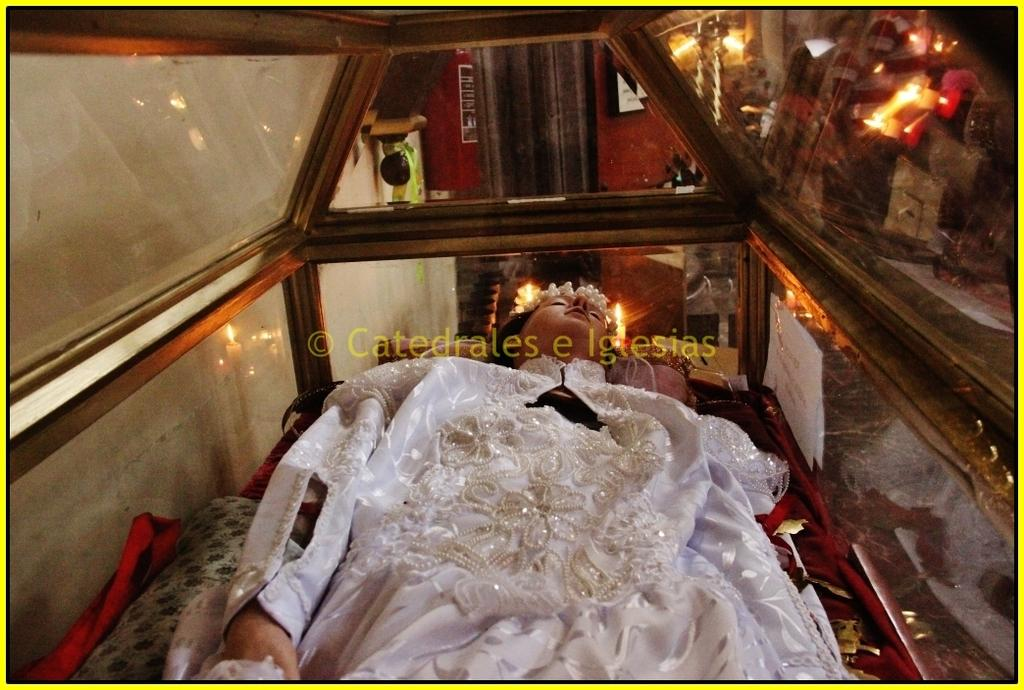What is the main subject of the image? There is a person in a coffin in the image. What can be seen in the background of the image? There are lights visible in the background of the image. What else is present in the image besides the person in the coffin? There are objects present in the image. How does the person in the coffin stretch their arms in the image? The person in the coffin cannot stretch their arms in the image, as they are in a coffin. What type of stove is visible in the image? There is no stove present in the image. 